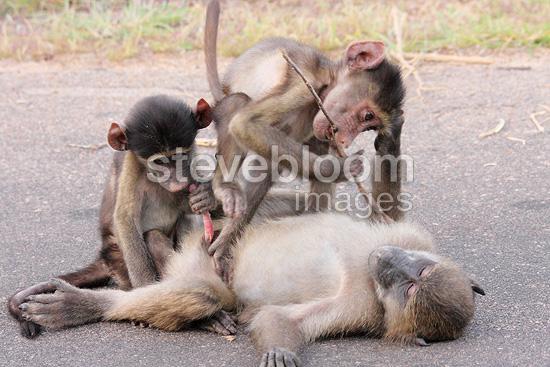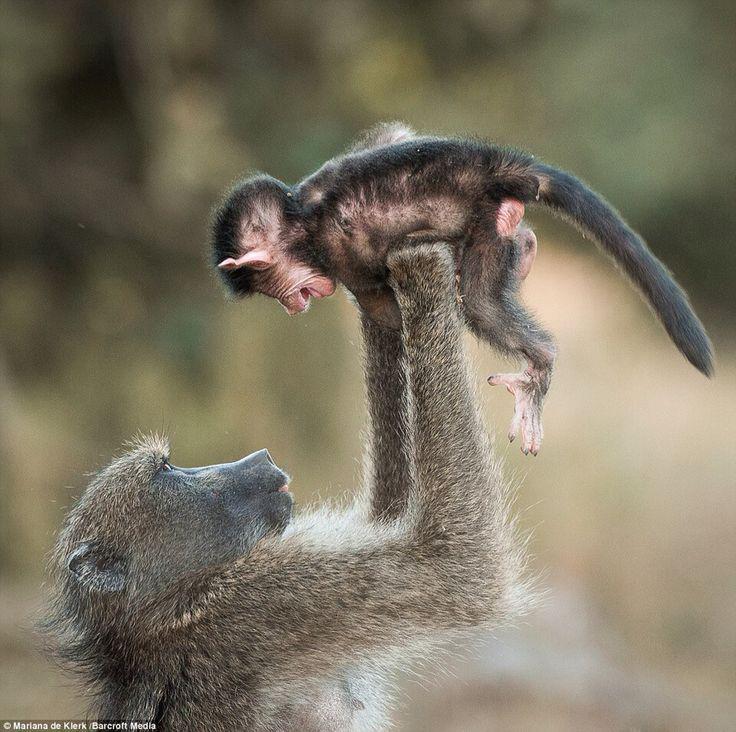The first image is the image on the left, the second image is the image on the right. Examine the images to the left and right. Is the description "There are no more than four monkeys." accurate? Answer yes or no. No. The first image is the image on the left, the second image is the image on the right. Analyze the images presented: Is the assertion "In one of the images monkeys are in a tree." valid? Answer yes or no. No. 